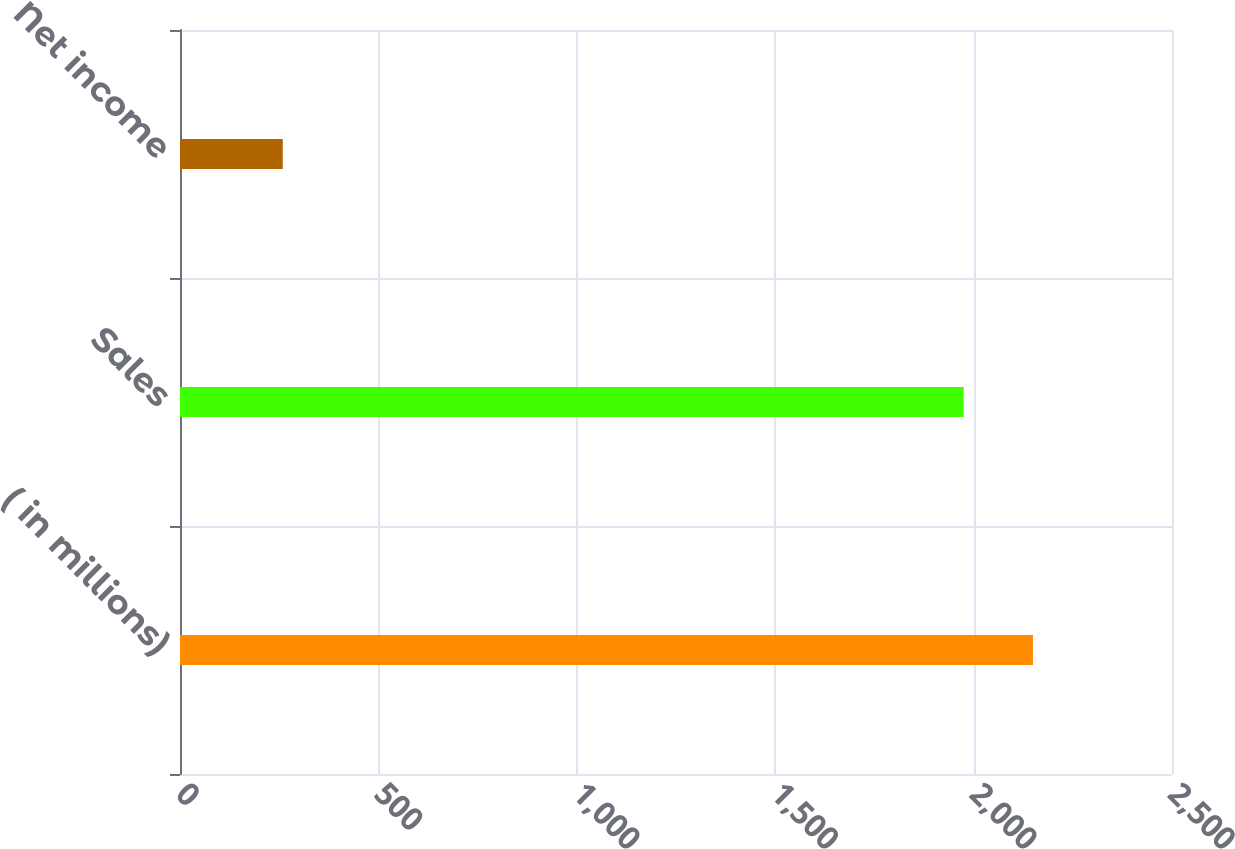Convert chart to OTSL. <chart><loc_0><loc_0><loc_500><loc_500><bar_chart><fcel>( in millions)<fcel>Sales<fcel>Net income<nl><fcel>2149.6<fcel>1975<fcel>259<nl></chart> 